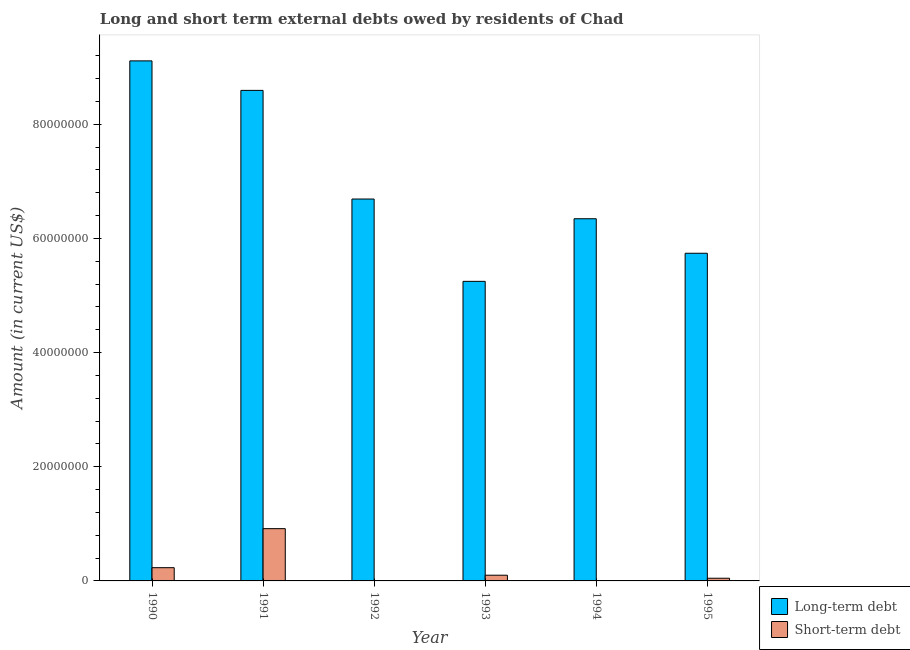Are the number of bars per tick equal to the number of legend labels?
Provide a short and direct response. No. How many bars are there on the 1st tick from the right?
Give a very brief answer. 2. What is the long-term debts owed by residents in 1995?
Ensure brevity in your answer.  5.74e+07. Across all years, what is the maximum long-term debts owed by residents?
Your answer should be compact. 9.11e+07. Across all years, what is the minimum long-term debts owed by residents?
Your response must be concise. 5.25e+07. In which year was the long-term debts owed by residents maximum?
Ensure brevity in your answer.  1990. What is the total long-term debts owed by residents in the graph?
Provide a short and direct response. 4.17e+08. What is the difference between the short-term debts owed by residents in 1990 and that in 1993?
Your answer should be very brief. 1.32e+06. What is the difference between the short-term debts owed by residents in 1995 and the long-term debts owed by residents in 1992?
Keep it short and to the point. 4.70e+05. What is the average long-term debts owed by residents per year?
Offer a very short reply. 6.96e+07. In the year 1991, what is the difference between the short-term debts owed by residents and long-term debts owed by residents?
Your response must be concise. 0. In how many years, is the short-term debts owed by residents greater than 44000000 US$?
Offer a very short reply. 0. What is the ratio of the short-term debts owed by residents in 1990 to that in 1993?
Keep it short and to the point. 2.32. What is the difference between the highest and the second highest short-term debts owed by residents?
Your answer should be very brief. 6.84e+06. What is the difference between the highest and the lowest short-term debts owed by residents?
Provide a succinct answer. 9.16e+06. Are all the bars in the graph horizontal?
Give a very brief answer. No. What is the difference between two consecutive major ticks on the Y-axis?
Offer a very short reply. 2.00e+07. Are the values on the major ticks of Y-axis written in scientific E-notation?
Your answer should be compact. No. Where does the legend appear in the graph?
Provide a succinct answer. Bottom right. How are the legend labels stacked?
Give a very brief answer. Vertical. What is the title of the graph?
Offer a very short reply. Long and short term external debts owed by residents of Chad. Does "Birth rate" appear as one of the legend labels in the graph?
Make the answer very short. No. What is the Amount (in current US$) of Long-term debt in 1990?
Provide a succinct answer. 9.11e+07. What is the Amount (in current US$) of Short-term debt in 1990?
Offer a terse response. 2.32e+06. What is the Amount (in current US$) in Long-term debt in 1991?
Provide a short and direct response. 8.59e+07. What is the Amount (in current US$) in Short-term debt in 1991?
Provide a short and direct response. 9.16e+06. What is the Amount (in current US$) in Long-term debt in 1992?
Offer a very short reply. 6.69e+07. What is the Amount (in current US$) in Short-term debt in 1992?
Give a very brief answer. 0. What is the Amount (in current US$) of Long-term debt in 1993?
Offer a terse response. 5.25e+07. What is the Amount (in current US$) in Short-term debt in 1993?
Provide a succinct answer. 1.00e+06. What is the Amount (in current US$) in Long-term debt in 1994?
Offer a very short reply. 6.35e+07. What is the Amount (in current US$) in Long-term debt in 1995?
Make the answer very short. 5.74e+07. What is the Amount (in current US$) in Short-term debt in 1995?
Offer a terse response. 4.70e+05. Across all years, what is the maximum Amount (in current US$) in Long-term debt?
Provide a succinct answer. 9.11e+07. Across all years, what is the maximum Amount (in current US$) of Short-term debt?
Keep it short and to the point. 9.16e+06. Across all years, what is the minimum Amount (in current US$) of Long-term debt?
Ensure brevity in your answer.  5.25e+07. What is the total Amount (in current US$) in Long-term debt in the graph?
Offer a very short reply. 4.17e+08. What is the total Amount (in current US$) of Short-term debt in the graph?
Provide a succinct answer. 1.30e+07. What is the difference between the Amount (in current US$) in Long-term debt in 1990 and that in 1991?
Make the answer very short. 5.17e+06. What is the difference between the Amount (in current US$) in Short-term debt in 1990 and that in 1991?
Give a very brief answer. -6.84e+06. What is the difference between the Amount (in current US$) of Long-term debt in 1990 and that in 1992?
Offer a very short reply. 2.42e+07. What is the difference between the Amount (in current US$) in Long-term debt in 1990 and that in 1993?
Your answer should be very brief. 3.86e+07. What is the difference between the Amount (in current US$) of Short-term debt in 1990 and that in 1993?
Ensure brevity in your answer.  1.32e+06. What is the difference between the Amount (in current US$) of Long-term debt in 1990 and that in 1994?
Offer a very short reply. 2.77e+07. What is the difference between the Amount (in current US$) of Long-term debt in 1990 and that in 1995?
Your response must be concise. 3.37e+07. What is the difference between the Amount (in current US$) of Short-term debt in 1990 and that in 1995?
Offer a terse response. 1.85e+06. What is the difference between the Amount (in current US$) of Long-term debt in 1991 and that in 1992?
Offer a terse response. 1.90e+07. What is the difference between the Amount (in current US$) of Long-term debt in 1991 and that in 1993?
Keep it short and to the point. 3.35e+07. What is the difference between the Amount (in current US$) in Short-term debt in 1991 and that in 1993?
Give a very brief answer. 8.16e+06. What is the difference between the Amount (in current US$) in Long-term debt in 1991 and that in 1994?
Your answer should be very brief. 2.25e+07. What is the difference between the Amount (in current US$) of Long-term debt in 1991 and that in 1995?
Offer a very short reply. 2.85e+07. What is the difference between the Amount (in current US$) of Short-term debt in 1991 and that in 1995?
Offer a very short reply. 8.69e+06. What is the difference between the Amount (in current US$) in Long-term debt in 1992 and that in 1993?
Ensure brevity in your answer.  1.44e+07. What is the difference between the Amount (in current US$) of Long-term debt in 1992 and that in 1994?
Your answer should be compact. 3.46e+06. What is the difference between the Amount (in current US$) of Long-term debt in 1992 and that in 1995?
Provide a short and direct response. 9.50e+06. What is the difference between the Amount (in current US$) in Long-term debt in 1993 and that in 1994?
Your answer should be very brief. -1.10e+07. What is the difference between the Amount (in current US$) of Long-term debt in 1993 and that in 1995?
Offer a very short reply. -4.92e+06. What is the difference between the Amount (in current US$) in Short-term debt in 1993 and that in 1995?
Your answer should be compact. 5.30e+05. What is the difference between the Amount (in current US$) in Long-term debt in 1994 and that in 1995?
Make the answer very short. 6.05e+06. What is the difference between the Amount (in current US$) in Long-term debt in 1990 and the Amount (in current US$) in Short-term debt in 1991?
Your response must be concise. 8.20e+07. What is the difference between the Amount (in current US$) in Long-term debt in 1990 and the Amount (in current US$) in Short-term debt in 1993?
Keep it short and to the point. 9.01e+07. What is the difference between the Amount (in current US$) in Long-term debt in 1990 and the Amount (in current US$) in Short-term debt in 1995?
Make the answer very short. 9.06e+07. What is the difference between the Amount (in current US$) of Long-term debt in 1991 and the Amount (in current US$) of Short-term debt in 1993?
Your response must be concise. 8.49e+07. What is the difference between the Amount (in current US$) in Long-term debt in 1991 and the Amount (in current US$) in Short-term debt in 1995?
Your answer should be compact. 8.55e+07. What is the difference between the Amount (in current US$) of Long-term debt in 1992 and the Amount (in current US$) of Short-term debt in 1993?
Offer a terse response. 6.59e+07. What is the difference between the Amount (in current US$) of Long-term debt in 1992 and the Amount (in current US$) of Short-term debt in 1995?
Your answer should be compact. 6.64e+07. What is the difference between the Amount (in current US$) in Long-term debt in 1993 and the Amount (in current US$) in Short-term debt in 1995?
Your answer should be very brief. 5.20e+07. What is the difference between the Amount (in current US$) in Long-term debt in 1994 and the Amount (in current US$) in Short-term debt in 1995?
Offer a terse response. 6.30e+07. What is the average Amount (in current US$) in Long-term debt per year?
Give a very brief answer. 6.96e+07. What is the average Amount (in current US$) in Short-term debt per year?
Your response must be concise. 2.16e+06. In the year 1990, what is the difference between the Amount (in current US$) of Long-term debt and Amount (in current US$) of Short-term debt?
Provide a short and direct response. 8.88e+07. In the year 1991, what is the difference between the Amount (in current US$) of Long-term debt and Amount (in current US$) of Short-term debt?
Keep it short and to the point. 7.68e+07. In the year 1993, what is the difference between the Amount (in current US$) of Long-term debt and Amount (in current US$) of Short-term debt?
Keep it short and to the point. 5.15e+07. In the year 1995, what is the difference between the Amount (in current US$) of Long-term debt and Amount (in current US$) of Short-term debt?
Make the answer very short. 5.69e+07. What is the ratio of the Amount (in current US$) in Long-term debt in 1990 to that in 1991?
Your answer should be compact. 1.06. What is the ratio of the Amount (in current US$) in Short-term debt in 1990 to that in 1991?
Provide a succinct answer. 0.25. What is the ratio of the Amount (in current US$) of Long-term debt in 1990 to that in 1992?
Give a very brief answer. 1.36. What is the ratio of the Amount (in current US$) in Long-term debt in 1990 to that in 1993?
Keep it short and to the point. 1.74. What is the ratio of the Amount (in current US$) of Short-term debt in 1990 to that in 1993?
Provide a short and direct response. 2.32. What is the ratio of the Amount (in current US$) of Long-term debt in 1990 to that in 1994?
Your answer should be compact. 1.44. What is the ratio of the Amount (in current US$) in Long-term debt in 1990 to that in 1995?
Offer a very short reply. 1.59. What is the ratio of the Amount (in current US$) of Short-term debt in 1990 to that in 1995?
Your response must be concise. 4.94. What is the ratio of the Amount (in current US$) of Long-term debt in 1991 to that in 1992?
Provide a succinct answer. 1.28. What is the ratio of the Amount (in current US$) of Long-term debt in 1991 to that in 1993?
Give a very brief answer. 1.64. What is the ratio of the Amount (in current US$) of Short-term debt in 1991 to that in 1993?
Ensure brevity in your answer.  9.16. What is the ratio of the Amount (in current US$) of Long-term debt in 1991 to that in 1994?
Your answer should be very brief. 1.35. What is the ratio of the Amount (in current US$) of Long-term debt in 1991 to that in 1995?
Your answer should be compact. 1.5. What is the ratio of the Amount (in current US$) of Short-term debt in 1991 to that in 1995?
Your answer should be very brief. 19.49. What is the ratio of the Amount (in current US$) of Long-term debt in 1992 to that in 1993?
Your answer should be compact. 1.27. What is the ratio of the Amount (in current US$) in Long-term debt in 1992 to that in 1994?
Offer a terse response. 1.05. What is the ratio of the Amount (in current US$) in Long-term debt in 1992 to that in 1995?
Make the answer very short. 1.17. What is the ratio of the Amount (in current US$) in Long-term debt in 1993 to that in 1994?
Make the answer very short. 0.83. What is the ratio of the Amount (in current US$) in Long-term debt in 1993 to that in 1995?
Provide a succinct answer. 0.91. What is the ratio of the Amount (in current US$) in Short-term debt in 1993 to that in 1995?
Keep it short and to the point. 2.13. What is the ratio of the Amount (in current US$) of Long-term debt in 1994 to that in 1995?
Your answer should be very brief. 1.11. What is the difference between the highest and the second highest Amount (in current US$) of Long-term debt?
Offer a terse response. 5.17e+06. What is the difference between the highest and the second highest Amount (in current US$) of Short-term debt?
Keep it short and to the point. 6.84e+06. What is the difference between the highest and the lowest Amount (in current US$) of Long-term debt?
Provide a short and direct response. 3.86e+07. What is the difference between the highest and the lowest Amount (in current US$) in Short-term debt?
Provide a succinct answer. 9.16e+06. 